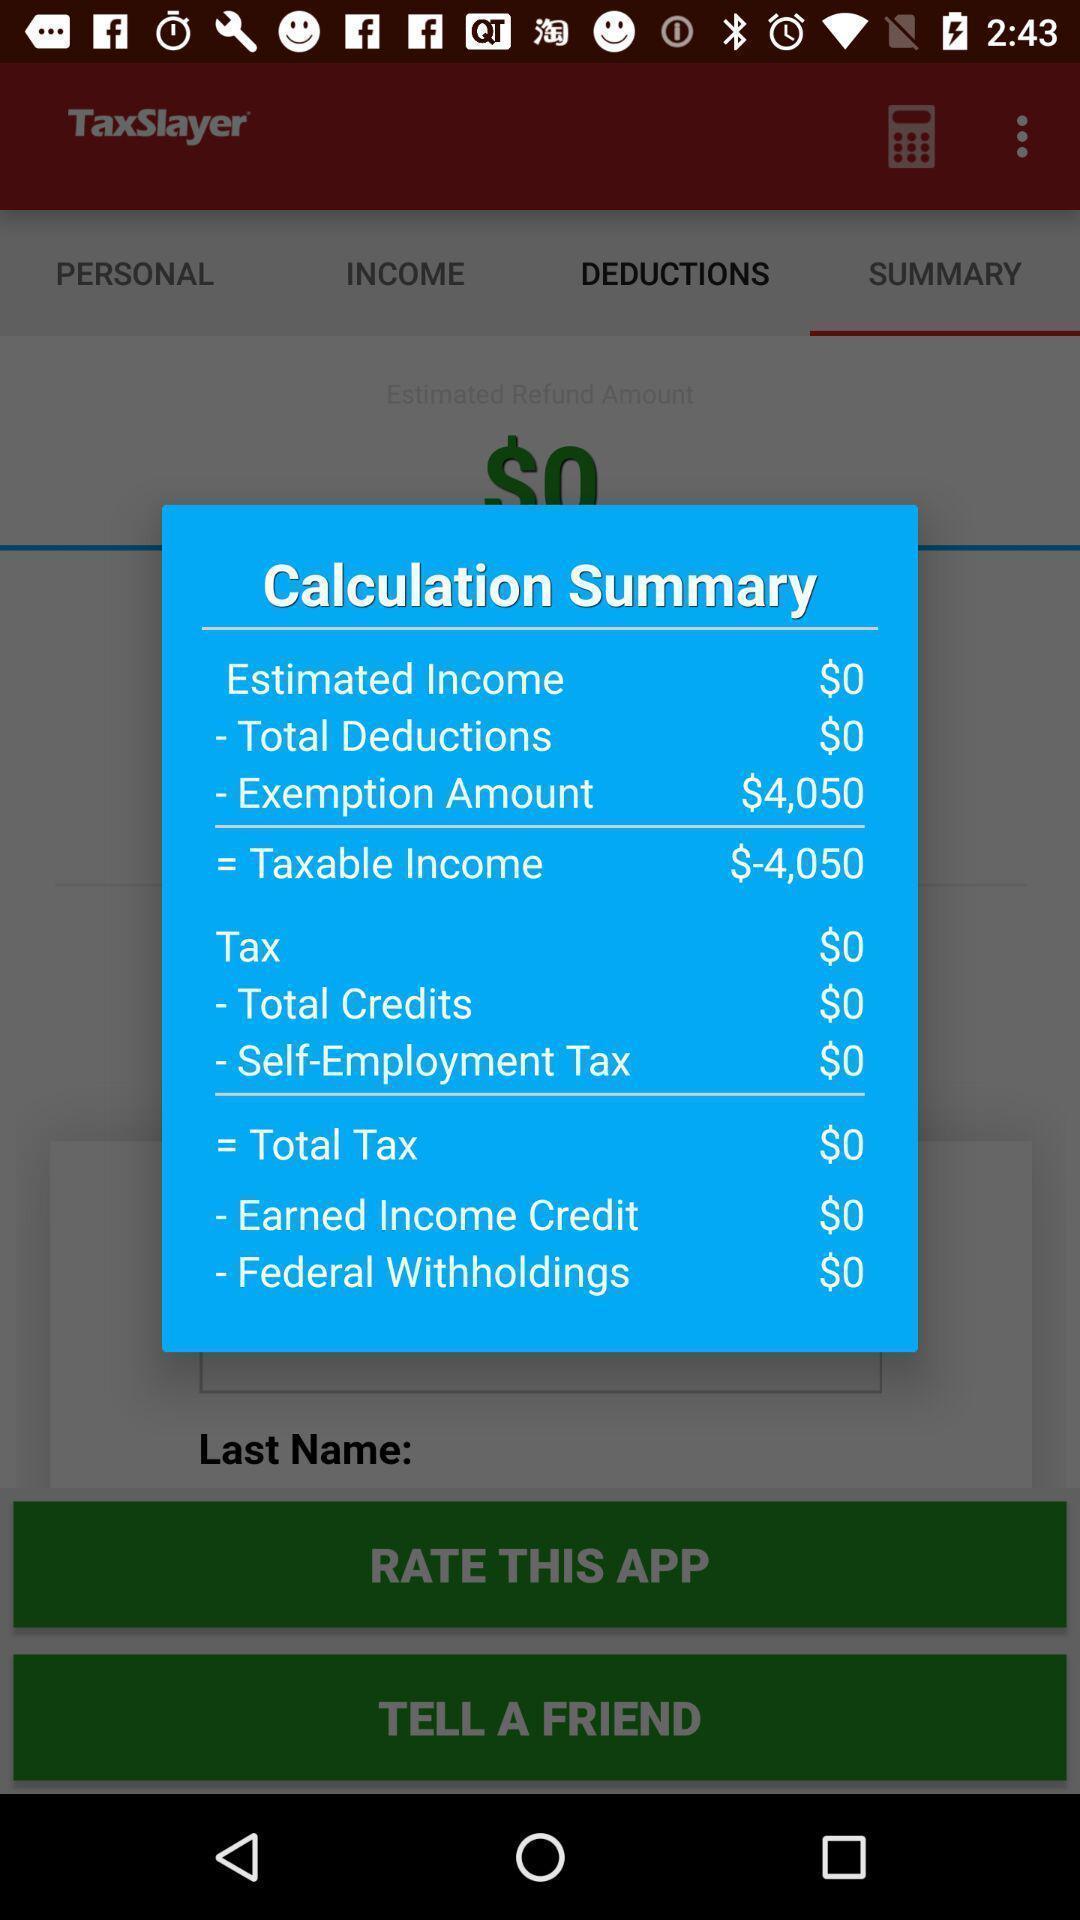Provide a description of this screenshot. Pop-up shows calculation summary in a financial app. 